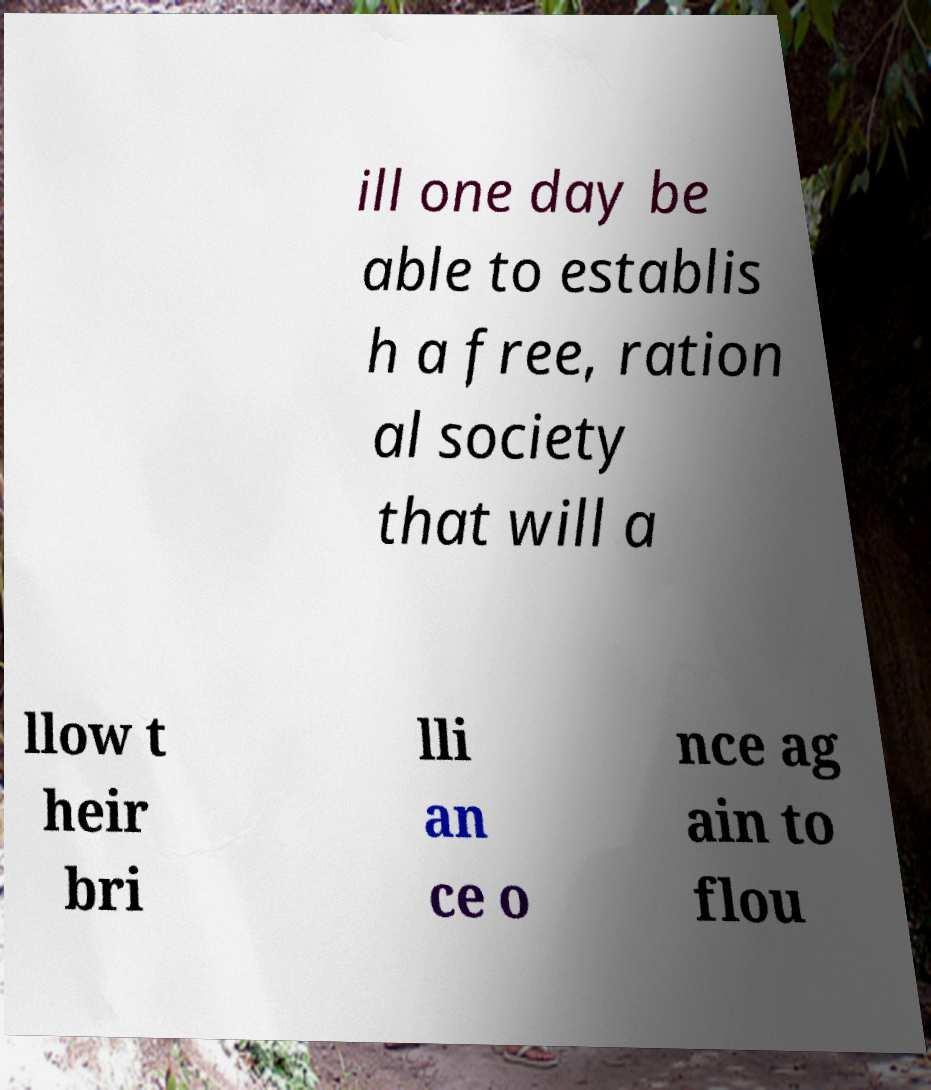Could you extract and type out the text from this image? ill one day be able to establis h a free, ration al society that will a llow t heir bri lli an ce o nce ag ain to flou 